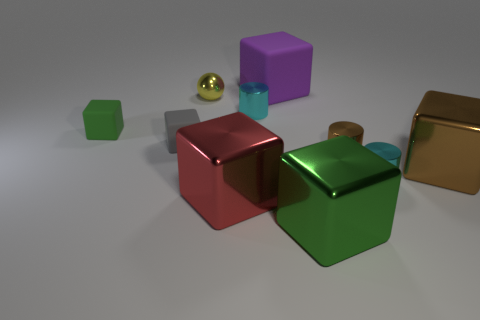Subtract all green cubes. How many cubes are left? 4 Subtract all green cubes. How many cubes are left? 4 Subtract all blocks. Subtract all small blue matte blocks. How many objects are left? 4 Add 1 green metallic things. How many green metallic things are left? 2 Add 7 tiny gray metallic blocks. How many tiny gray metallic blocks exist? 7 Subtract 1 yellow balls. How many objects are left? 9 Subtract all cylinders. How many objects are left? 7 Subtract 1 cylinders. How many cylinders are left? 2 Subtract all cyan spheres. Subtract all brown cubes. How many spheres are left? 1 Subtract all cyan cubes. How many brown cylinders are left? 1 